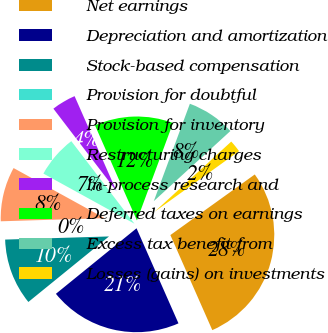Convert chart. <chart><loc_0><loc_0><loc_500><loc_500><pie_chart><fcel>Net earnings<fcel>Depreciation and amortization<fcel>Stock-based compensation<fcel>Provision for doubtful<fcel>Provision for inventory<fcel>Restructuring charges<fcel>In-process research and<fcel>Deferred taxes on earnings<fcel>Excess tax benefit from<fcel>Losses (gains) on investments<nl><fcel>28.3%<fcel>20.75%<fcel>10.38%<fcel>0.0%<fcel>8.49%<fcel>6.6%<fcel>3.78%<fcel>12.26%<fcel>7.55%<fcel>1.89%<nl></chart> 